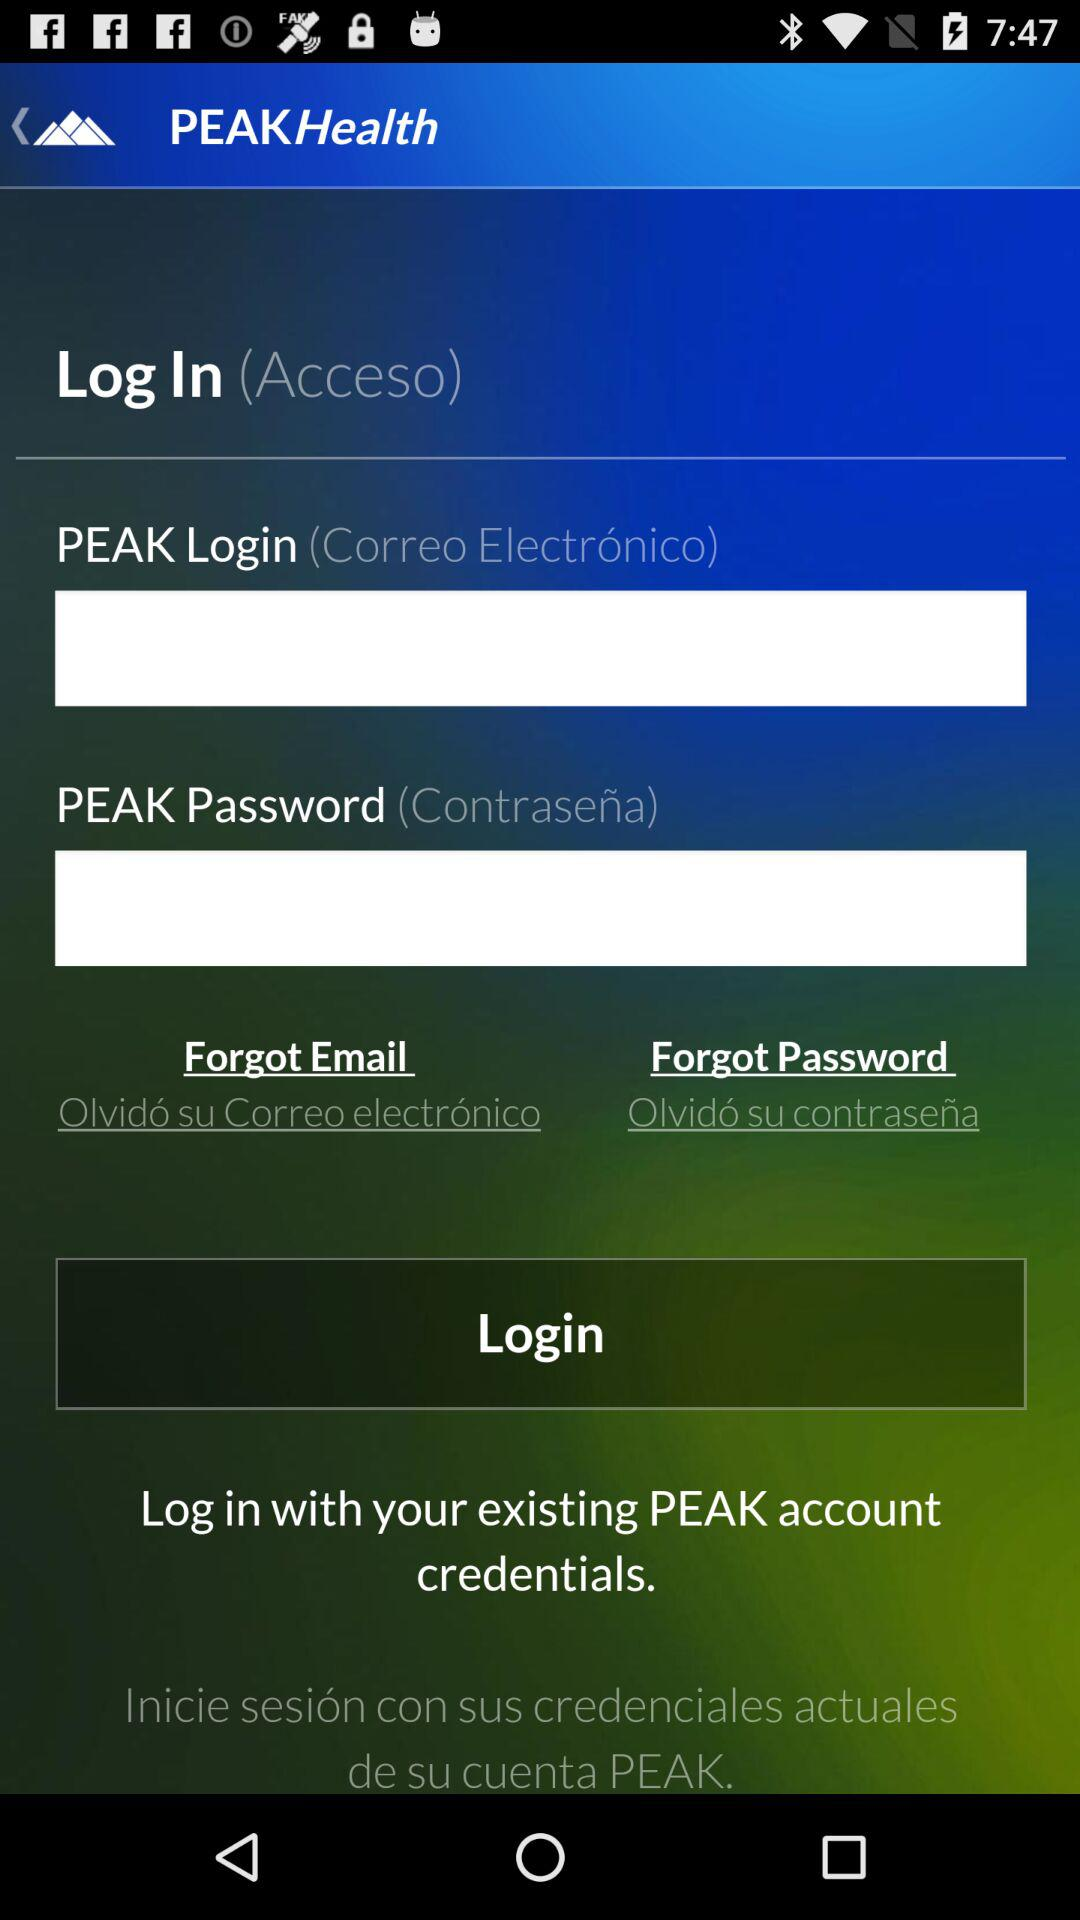What is the application name? The application name is "PEAKHealth". 